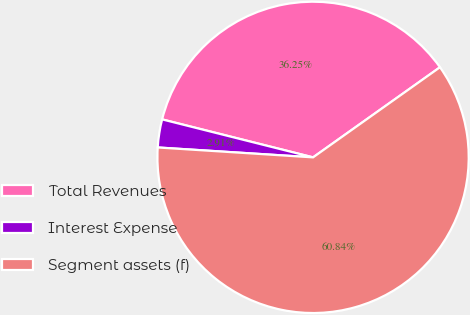Convert chart to OTSL. <chart><loc_0><loc_0><loc_500><loc_500><pie_chart><fcel>Total Revenues<fcel>Interest Expense<fcel>Segment assets (f)<nl><fcel>36.25%<fcel>2.91%<fcel>60.84%<nl></chart> 